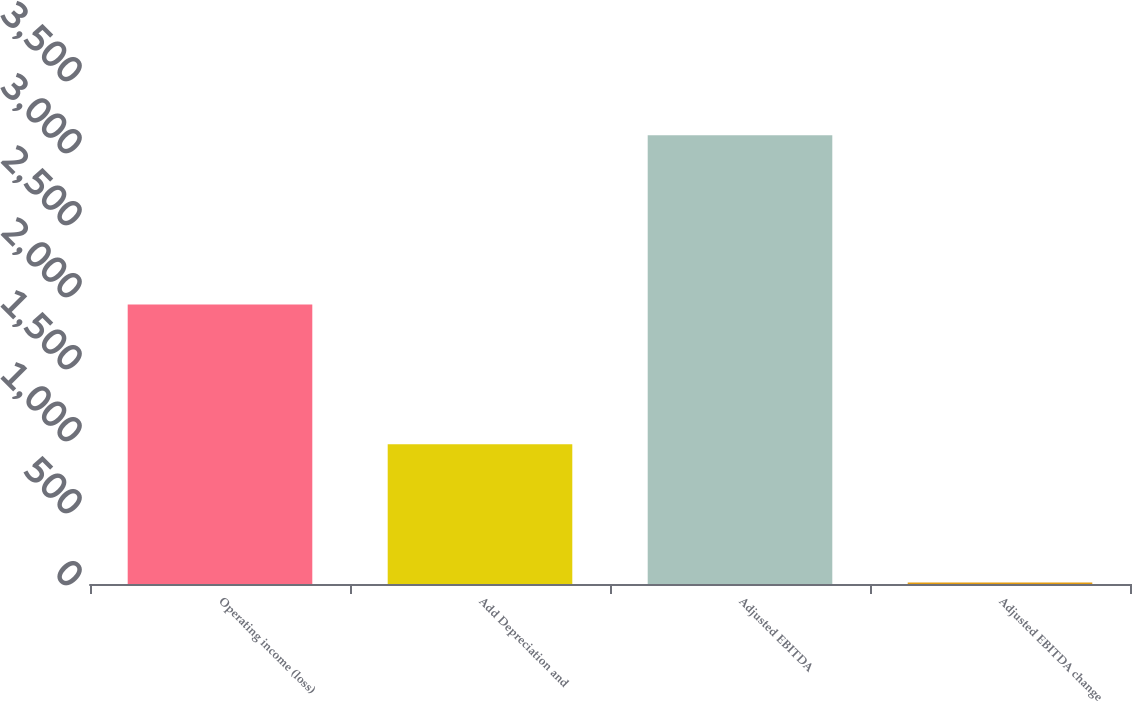Convert chart to OTSL. <chart><loc_0><loc_0><loc_500><loc_500><bar_chart><fcel>Operating income (loss)<fcel>Add Depreciation and<fcel>Adjusted EBITDA<fcel>Adjusted EBITDA change<nl><fcel>1941.5<fcel>970.7<fcel>3115.5<fcel>11<nl></chart> 